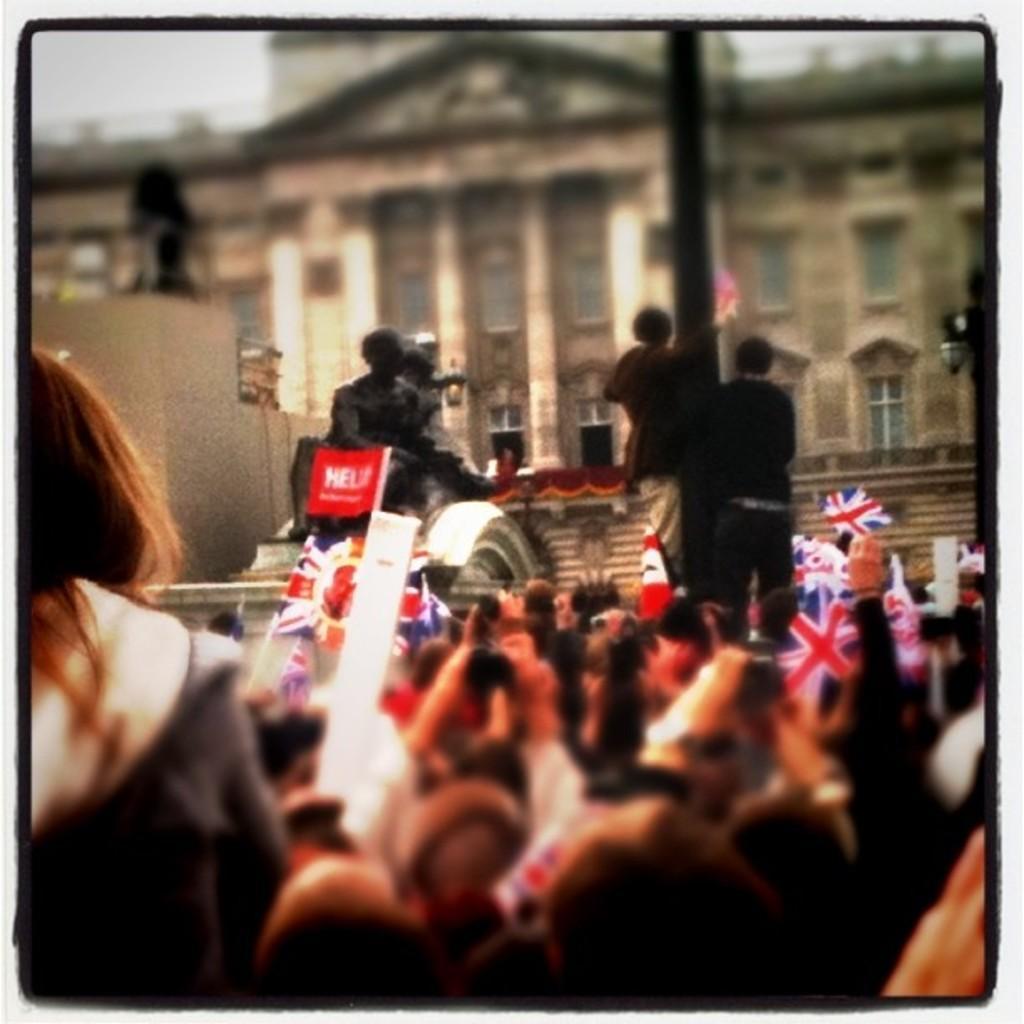In one or two sentences, can you explain what this image depicts? The picture is blurred where we can see a few people standing here by holding flags, here we can see statues and buildings. 